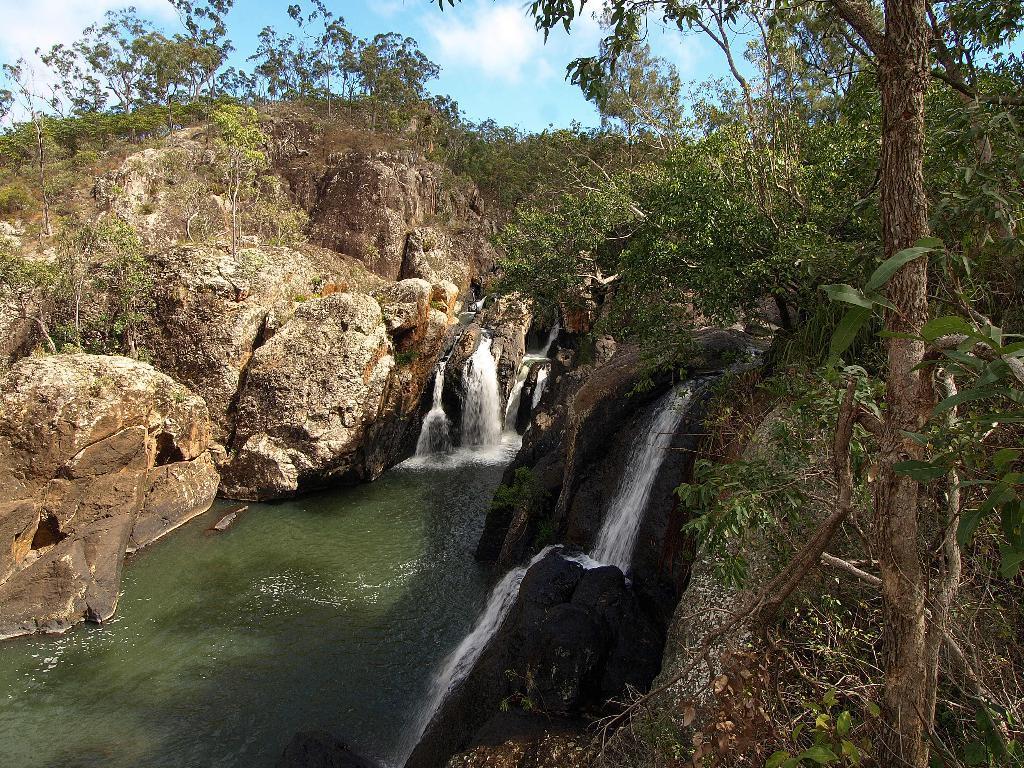Please provide a concise description of this image. In this picture we can see trees, waterfall and rocks. In the background of the image we can see sky with clouds. 